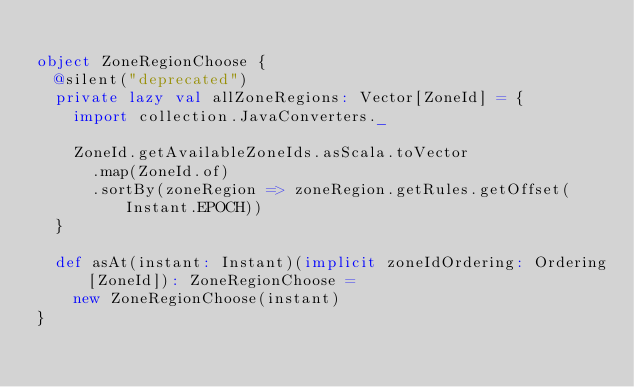Convert code to text. <code><loc_0><loc_0><loc_500><loc_500><_Scala_>
object ZoneRegionChoose {
  @silent("deprecated")
  private lazy val allZoneRegions: Vector[ZoneId] = {
    import collection.JavaConverters._

    ZoneId.getAvailableZoneIds.asScala.toVector
      .map(ZoneId.of)
      .sortBy(zoneRegion => zoneRegion.getRules.getOffset(Instant.EPOCH))
  }

  def asAt(instant: Instant)(implicit zoneIdOrdering: Ordering[ZoneId]): ZoneRegionChoose =
    new ZoneRegionChoose(instant)
}
</code> 